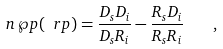<formula> <loc_0><loc_0><loc_500><loc_500>n \, \wp p ( \ r p ) = \frac { D _ { s } D _ { i } } { D _ { s } R _ { i } } - \frac { R _ { s } D _ { i } } { R _ { s } R _ { i } } \quad ,</formula> 